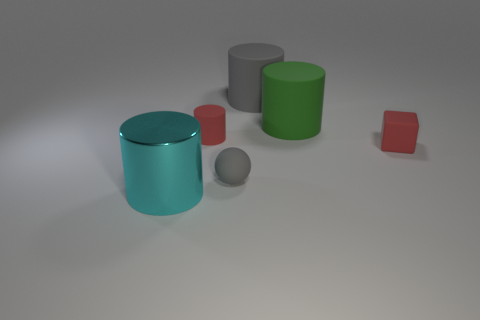Add 1 large matte things. How many objects exist? 7 Subtract all red cylinders. How many cylinders are left? 3 Subtract all large cyan metal cylinders. How many cylinders are left? 3 Subtract all cylinders. How many objects are left? 2 Subtract 3 cylinders. How many cylinders are left? 1 Subtract all blue spheres. Subtract all cyan cylinders. How many spheres are left? 1 Subtract all brown cubes. How many blue spheres are left? 0 Subtract all large brown balls. Subtract all gray things. How many objects are left? 4 Add 2 big green objects. How many big green objects are left? 3 Add 1 small gray balls. How many small gray balls exist? 2 